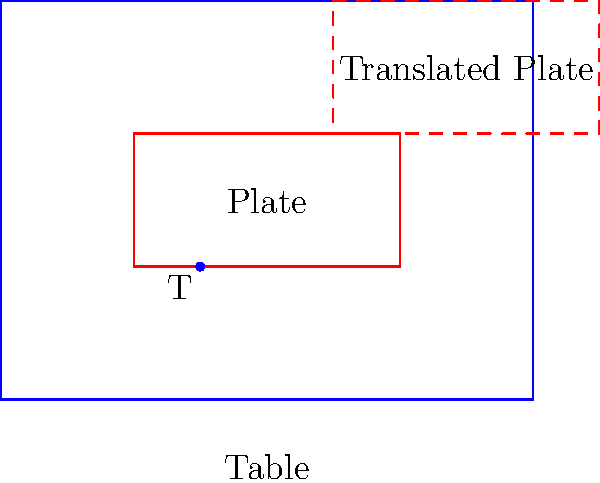In setting a charming table arrangement, you decide to move a plate to create a more visually appealing layout. The original plate is represented by the solid red rectangle, and you want to move it to the position shown by the dashed red rectangle. What is the translation vector $T$ that describes this movement? To find the translation vector, we need to follow these steps:

1. Identify the starting position of the plate:
   The original plate's center is at $(2, 1.5)$

2. Identify the final position of the plate:
   The translated plate's center is at $(3.5, 2.5)$

3. Calculate the difference between the final and starting positions:
   $x$ component: $3.5 - 2 = 1.5$
   $y$ component: $2.5 - 1.5 = 1$

4. Express the translation as a vector:
   The translation vector $T$ is $(1.5, 1)$

This vector represents moving the plate 1.5 units to the right and 1 unit up, which aligns with the movement shown in the diagram.
Answer: $T = (1.5, 1)$ 